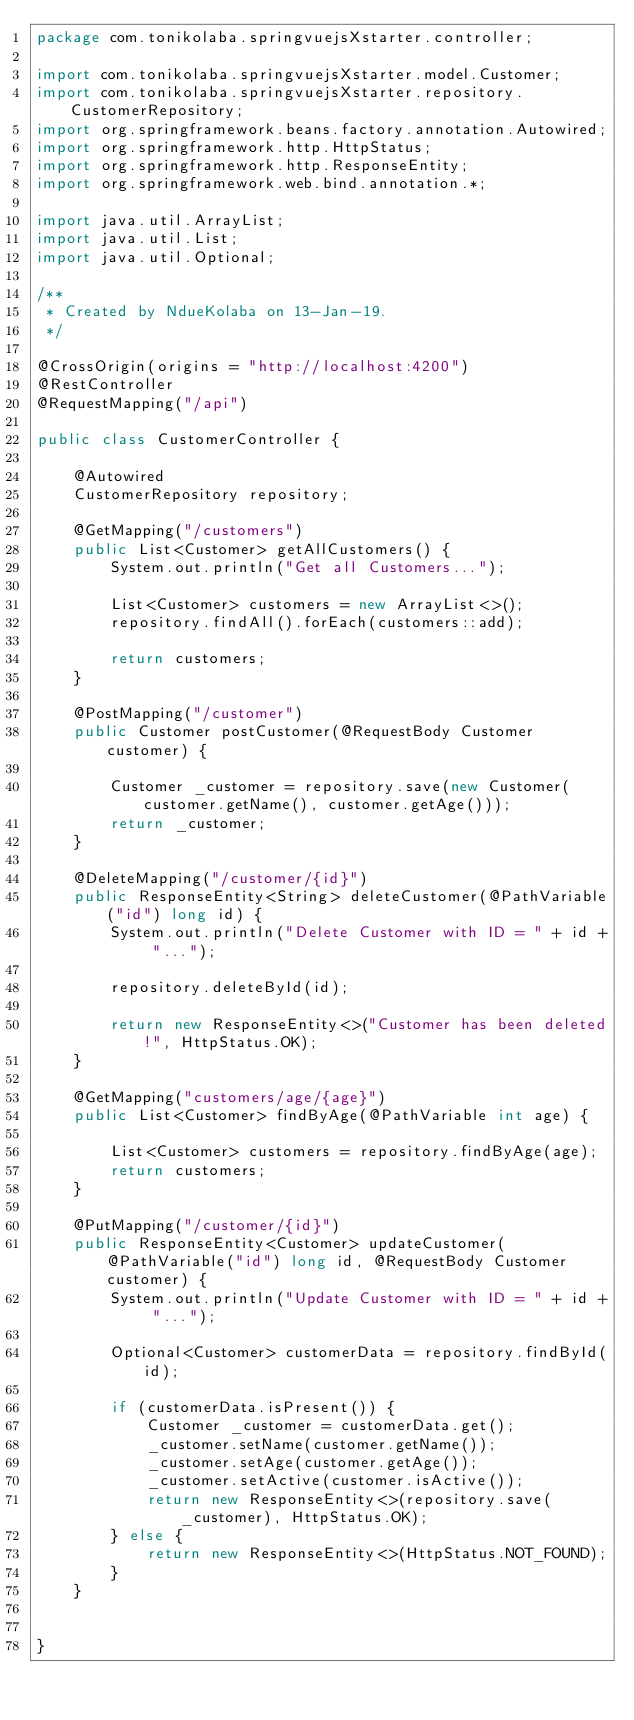<code> <loc_0><loc_0><loc_500><loc_500><_Java_>package com.tonikolaba.springvuejsXstarter.controller;

import com.tonikolaba.springvuejsXstarter.model.Customer;
import com.tonikolaba.springvuejsXstarter.repository.CustomerRepository;
import org.springframework.beans.factory.annotation.Autowired;
import org.springframework.http.HttpStatus;
import org.springframework.http.ResponseEntity;
import org.springframework.web.bind.annotation.*;

import java.util.ArrayList;
import java.util.List;
import java.util.Optional;

/**
 * Created by NdueKolaba on 13-Jan-19.
 */

@CrossOrigin(origins = "http://localhost:4200")
@RestController
@RequestMapping("/api")

public class CustomerController {

    @Autowired
    CustomerRepository repository;

    @GetMapping("/customers")
    public List<Customer> getAllCustomers() {
        System.out.println("Get all Customers...");

        List<Customer> customers = new ArrayList<>();
        repository.findAll().forEach(customers::add);

        return customers;
    }

    @PostMapping("/customer")
    public Customer postCustomer(@RequestBody Customer customer) {

        Customer _customer = repository.save(new Customer(customer.getName(), customer.getAge()));
        return _customer;
    }

    @DeleteMapping("/customer/{id}")
    public ResponseEntity<String> deleteCustomer(@PathVariable("id") long id) {
        System.out.println("Delete Customer with ID = " + id + "...");

        repository.deleteById(id);

        return new ResponseEntity<>("Customer has been deleted!", HttpStatus.OK);
    }

    @GetMapping("customers/age/{age}")
    public List<Customer> findByAge(@PathVariable int age) {

        List<Customer> customers = repository.findByAge(age);
        return customers;
    }

    @PutMapping("/customer/{id}")
    public ResponseEntity<Customer> updateCustomer(@PathVariable("id") long id, @RequestBody Customer customer) {
        System.out.println("Update Customer with ID = " + id + "...");

        Optional<Customer> customerData = repository.findById(id);

        if (customerData.isPresent()) {
            Customer _customer = customerData.get();
            _customer.setName(customer.getName());
            _customer.setAge(customer.getAge());
            _customer.setActive(customer.isActive());
            return new ResponseEntity<>(repository.save(_customer), HttpStatus.OK);
        } else {
            return new ResponseEntity<>(HttpStatus.NOT_FOUND);
        }
    }


}
</code> 